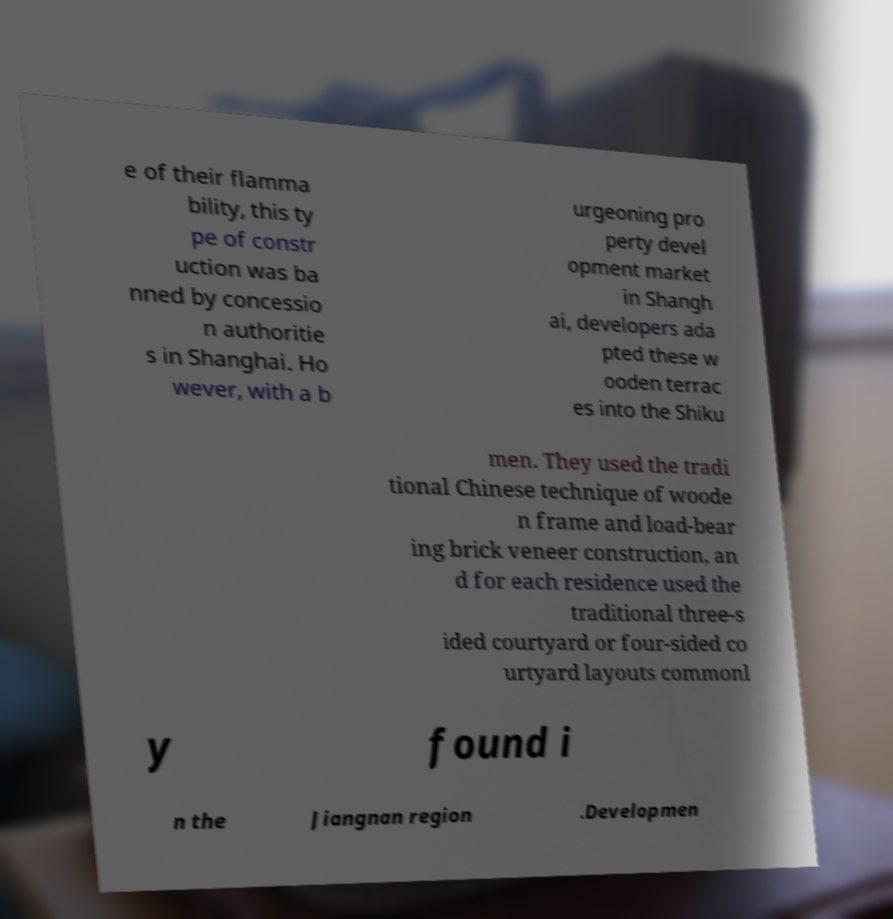There's text embedded in this image that I need extracted. Can you transcribe it verbatim? e of their flamma bility, this ty pe of constr uction was ba nned by concessio n authoritie s in Shanghai. Ho wever, with a b urgeoning pro perty devel opment market in Shangh ai, developers ada pted these w ooden terrac es into the Shiku men. They used the tradi tional Chinese technique of woode n frame and load-bear ing brick veneer construction, an d for each residence used the traditional three-s ided courtyard or four-sided co urtyard layouts commonl y found i n the Jiangnan region .Developmen 